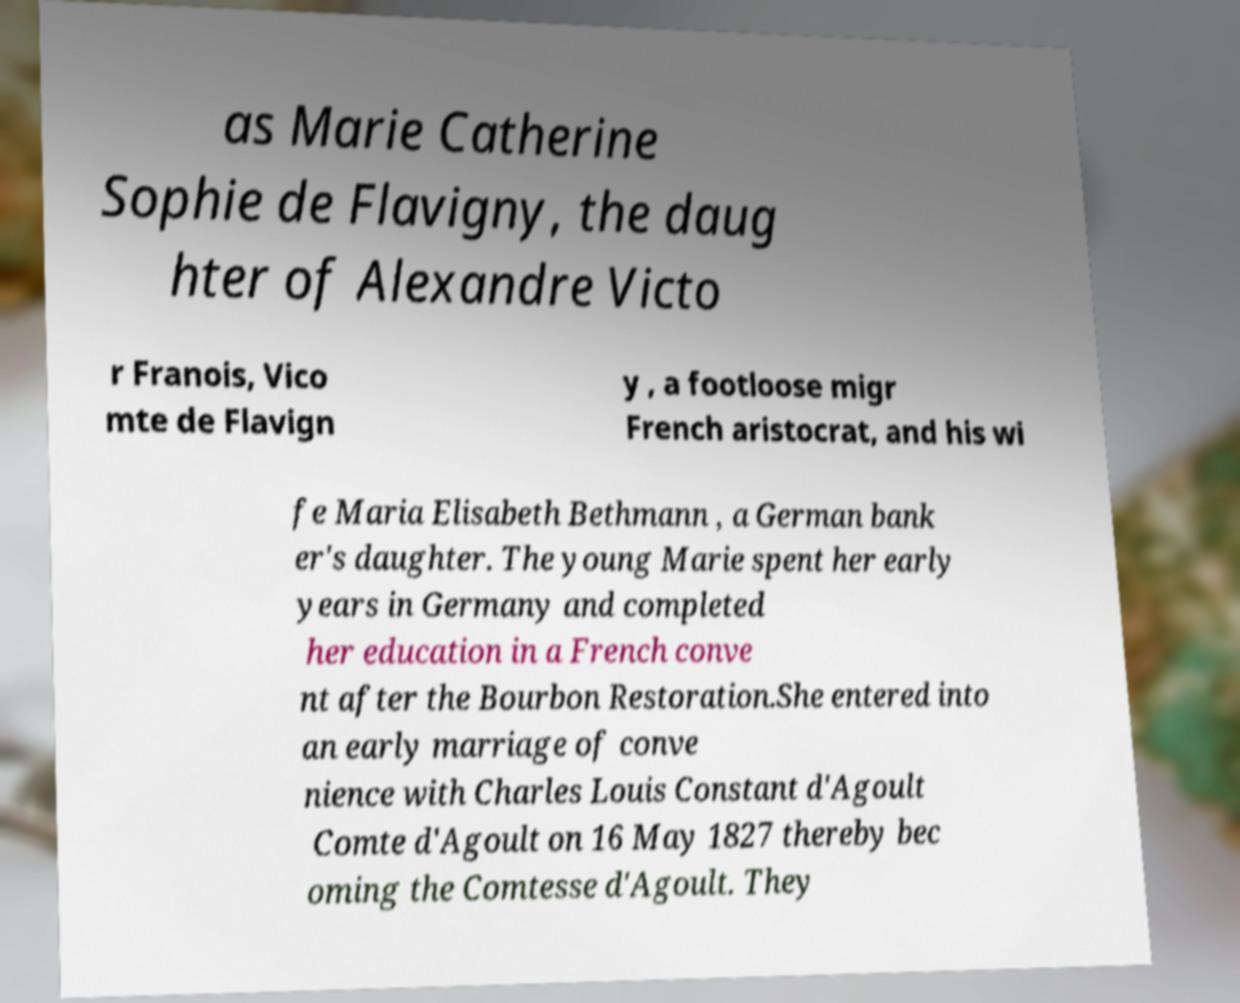What messages or text are displayed in this image? I need them in a readable, typed format. as Marie Catherine Sophie de Flavigny, the daug hter of Alexandre Victo r Franois, Vico mte de Flavign y , a footloose migr French aristocrat, and his wi fe Maria Elisabeth Bethmann , a German bank er's daughter. The young Marie spent her early years in Germany and completed her education in a French conve nt after the Bourbon Restoration.She entered into an early marriage of conve nience with Charles Louis Constant d'Agoult Comte d'Agoult on 16 May 1827 thereby bec oming the Comtesse d'Agoult. They 